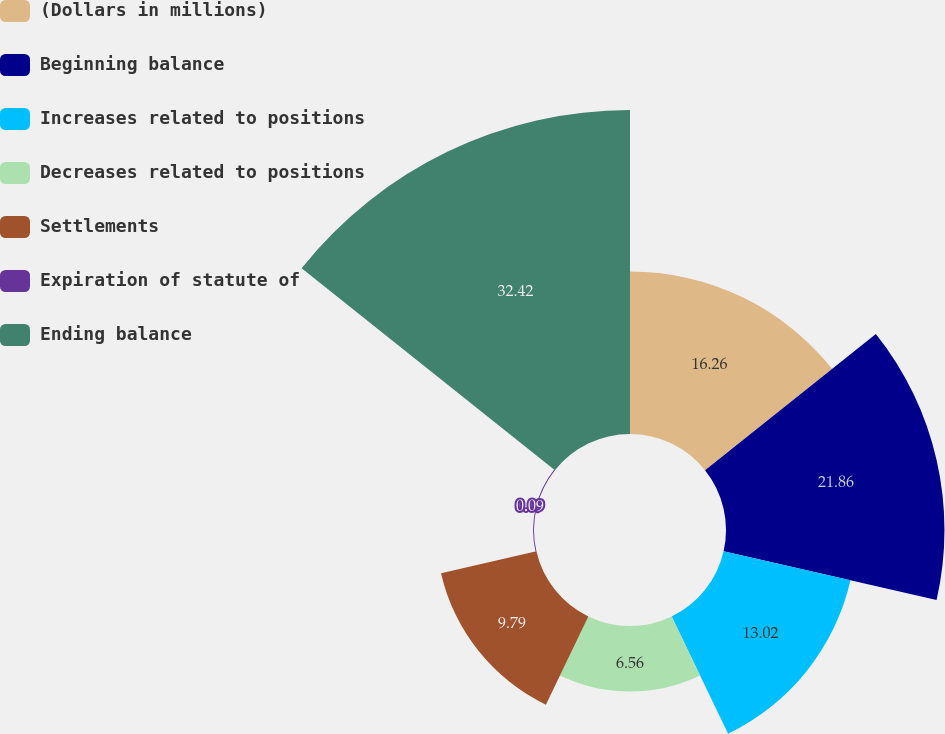<chart> <loc_0><loc_0><loc_500><loc_500><pie_chart><fcel>(Dollars in millions)<fcel>Beginning balance<fcel>Increases related to positions<fcel>Decreases related to positions<fcel>Settlements<fcel>Expiration of statute of<fcel>Ending balance<nl><fcel>16.26%<fcel>21.86%<fcel>13.02%<fcel>6.56%<fcel>9.79%<fcel>0.09%<fcel>32.42%<nl></chart> 